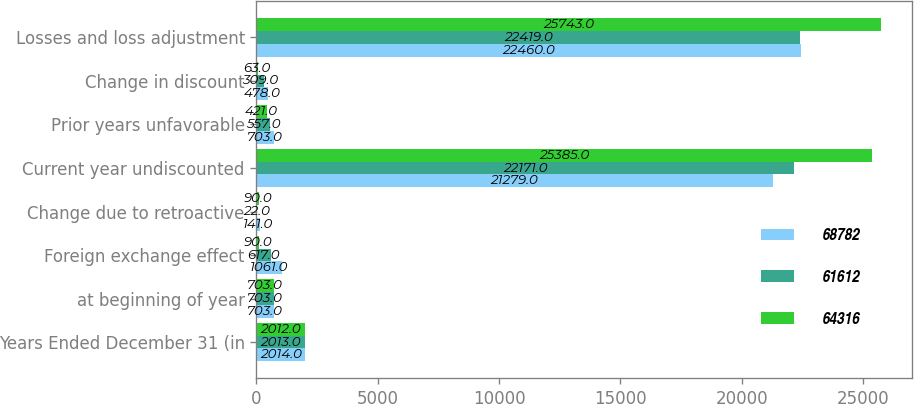Convert chart to OTSL. <chart><loc_0><loc_0><loc_500><loc_500><stacked_bar_chart><ecel><fcel>Years Ended December 31 (in<fcel>at beginning of year<fcel>Foreign exchange effect<fcel>Change due to retroactive<fcel>Current year undiscounted<fcel>Prior years unfavorable<fcel>Change in discount<fcel>Losses and loss adjustment<nl><fcel>68782<fcel>2014<fcel>703<fcel>1061<fcel>141<fcel>21279<fcel>703<fcel>478<fcel>22460<nl><fcel>61612<fcel>2013<fcel>703<fcel>617<fcel>22<fcel>22171<fcel>557<fcel>309<fcel>22419<nl><fcel>64316<fcel>2012<fcel>703<fcel>90<fcel>90<fcel>25385<fcel>421<fcel>63<fcel>25743<nl></chart> 